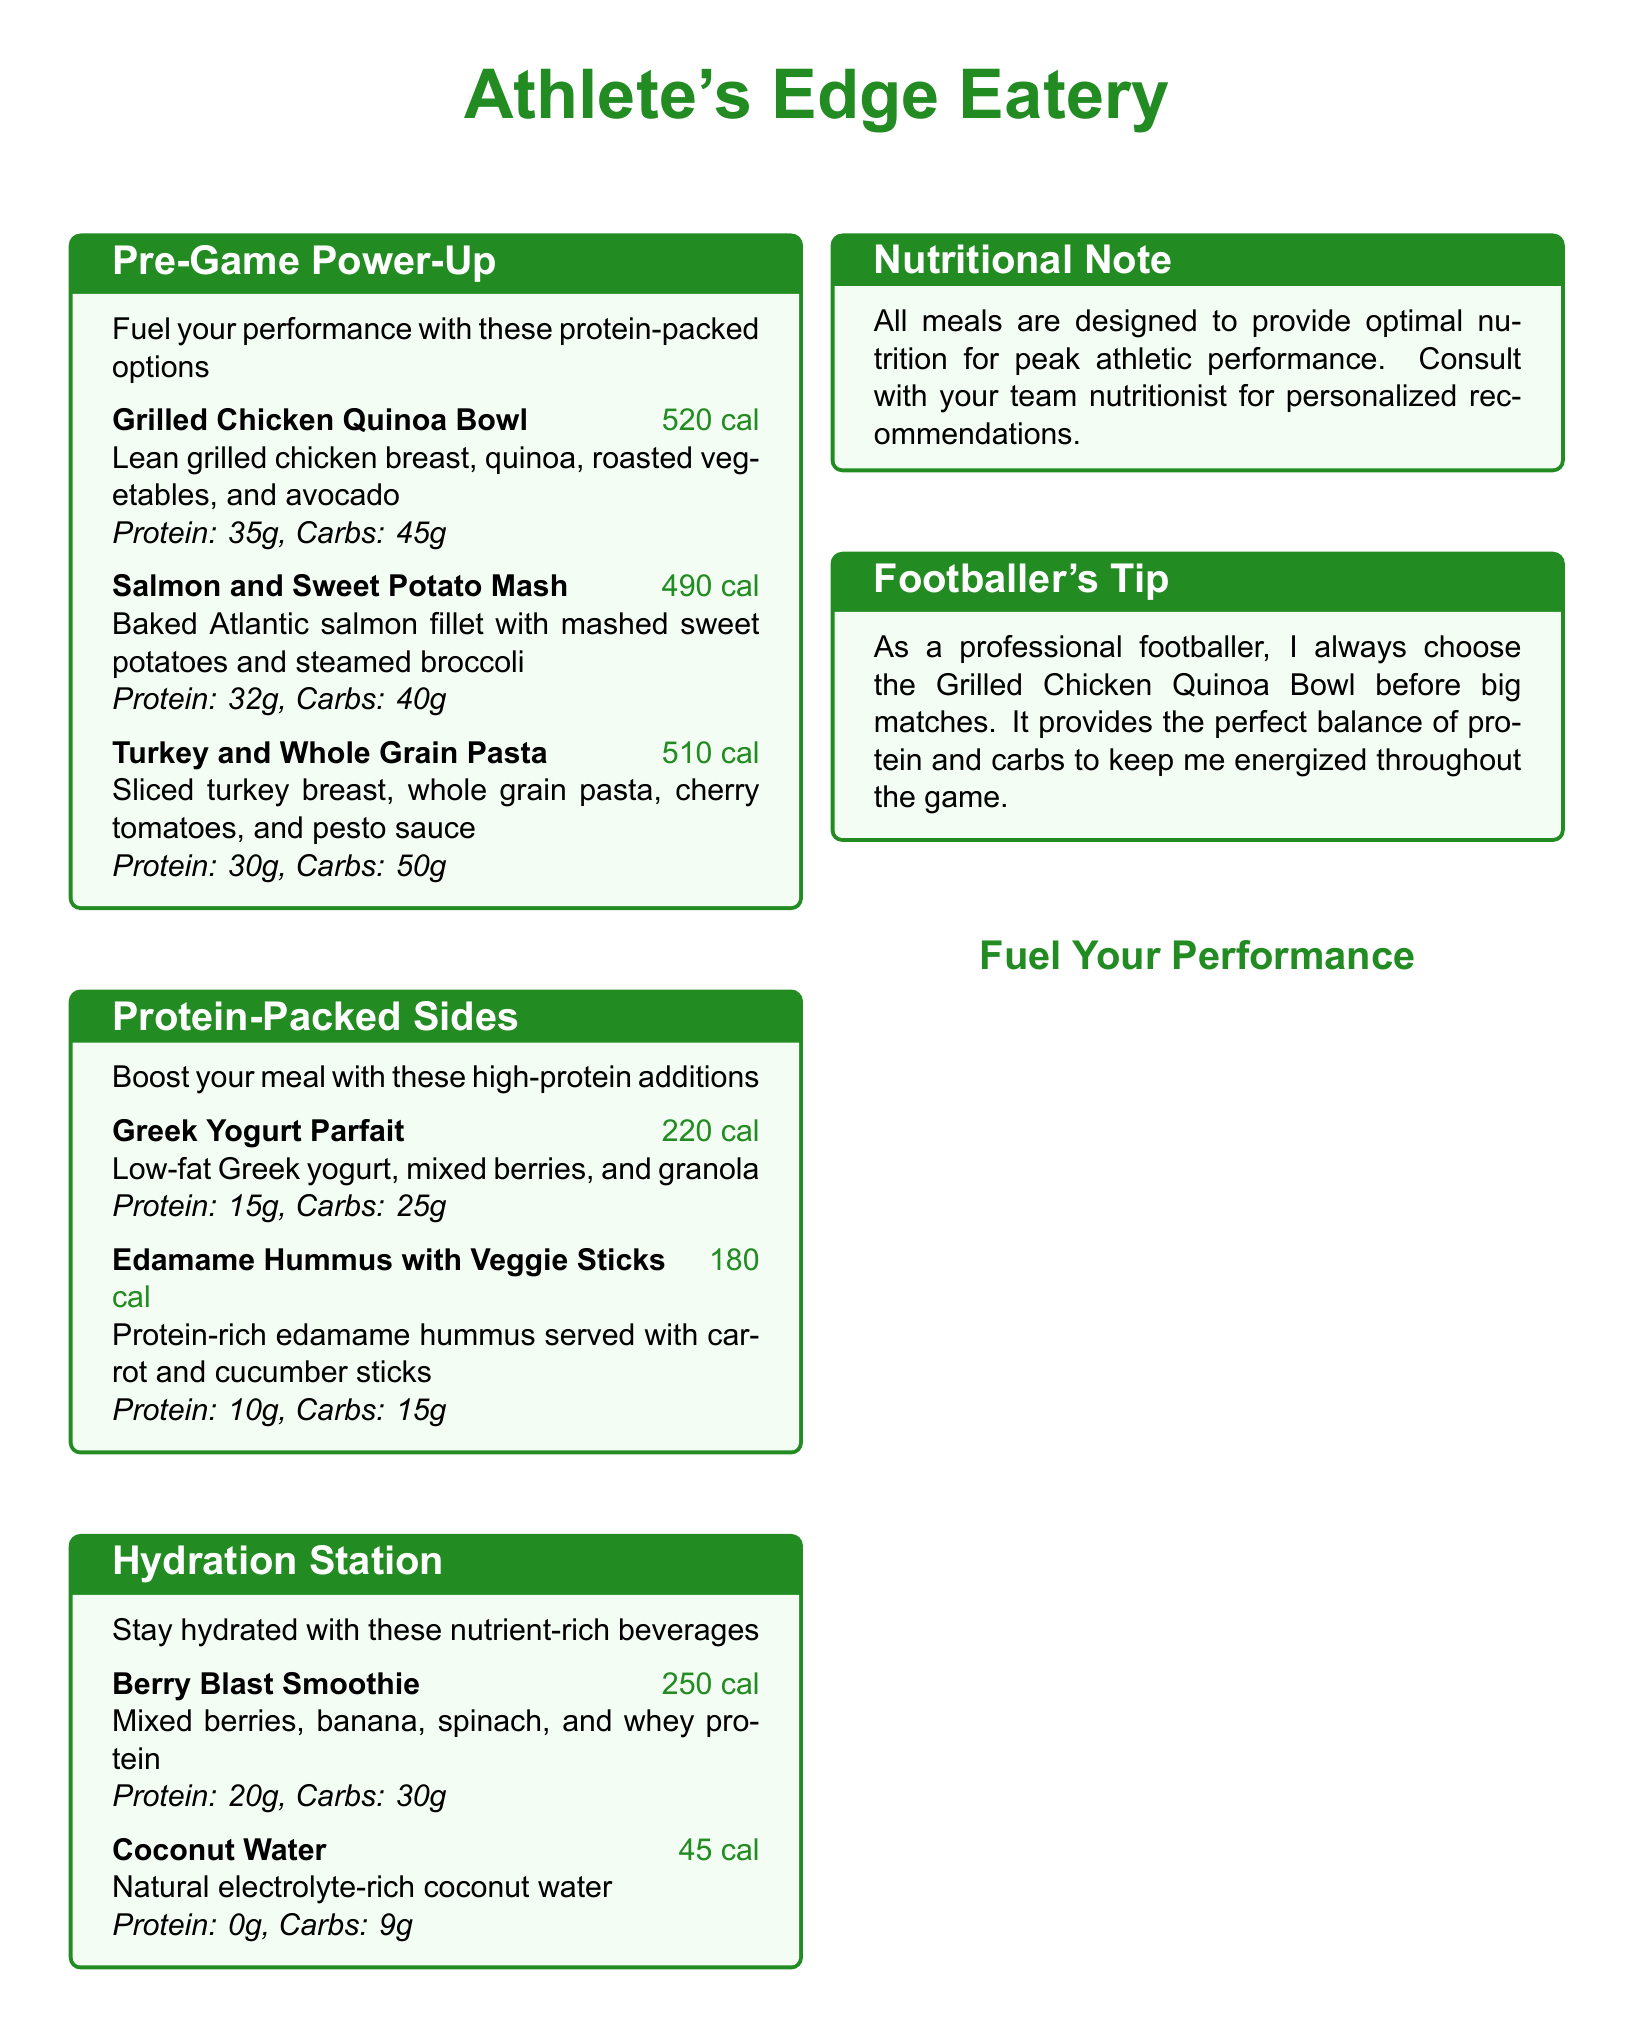What is the calorie count of the Grilled Chicken Quinoa Bowl? The calorie count for the Grilled Chicken Quinoa Bowl is explicitly stated in the menu.
Answer: 520 cal How much protein does the Salmon and Sweet Potato Mash contain? The protein content for the Salmon and Sweet Potato Mash is provided in the nutritional information section.
Answer: 32g What type of pasta is used in the Turkey and Whole Grain Pasta? The menu specifically mentions the type of pasta used in this dish.
Answer: Whole Grain Pasta Which drink has the highest protein content? To answer this, we compare the protein contents of the beverages listed in the Hydration Station section.
Answer: Berry Blast Smoothie What do all meals provide according to the Nutritional Note? The Nutritional Note summarizes the purpose of the meals listed in the menu.
Answer: Optimal nutrition for peak athletic performance What is recommended for personalized nutrition advice? The Nutritional Note suggests seeking guidance for tailored dietary plans.
Answer: Consult with your team nutritionist Which pre-game meal option is highlighted by a footballer's tip? The Footballer's Tip section indicates which meal the athlete prefers before matches.
Answer: Grilled Chicken Quinoa Bowl How many grams of protein are in the Greek Yogurt Parfait? The protein content for the Greek Yogurt Parfait is provided in the menu description.
Answer: 15g What is the calorie count of Coconut Water? The menu states the calorie count for Coconut Water clearly.
Answer: 45 cal 